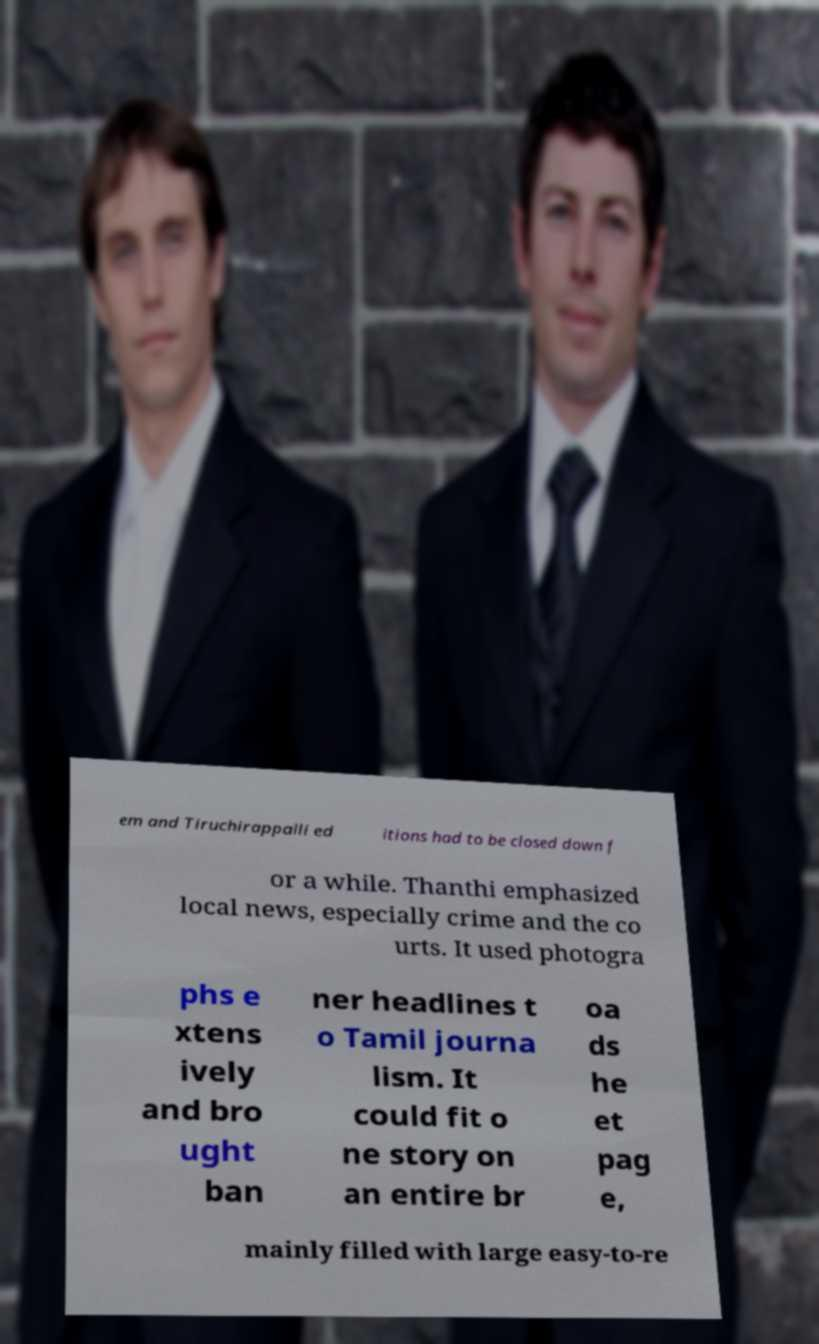Could you extract and type out the text from this image? em and Tiruchirappalli ed itions had to be closed down f or a while. Thanthi emphasized local news, especially crime and the co urts. It used photogra phs e xtens ively and bro ught ban ner headlines t o Tamil journa lism. It could fit o ne story on an entire br oa ds he et pag e, mainly filled with large easy-to-re 